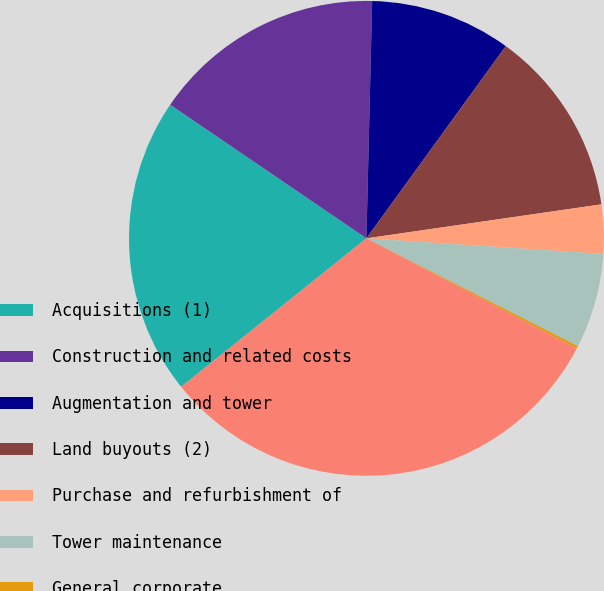Convert chart to OTSL. <chart><loc_0><loc_0><loc_500><loc_500><pie_chart><fcel>Acquisitions (1)<fcel>Construction and related costs<fcel>Augmentation and tower<fcel>Land buyouts (2)<fcel>Purchase and refurbishment of<fcel>Tower maintenance<fcel>General corporate<fcel>Total cash capital<nl><fcel>20.27%<fcel>15.87%<fcel>9.6%<fcel>12.73%<fcel>3.33%<fcel>6.46%<fcel>0.19%<fcel>31.55%<nl></chart> 